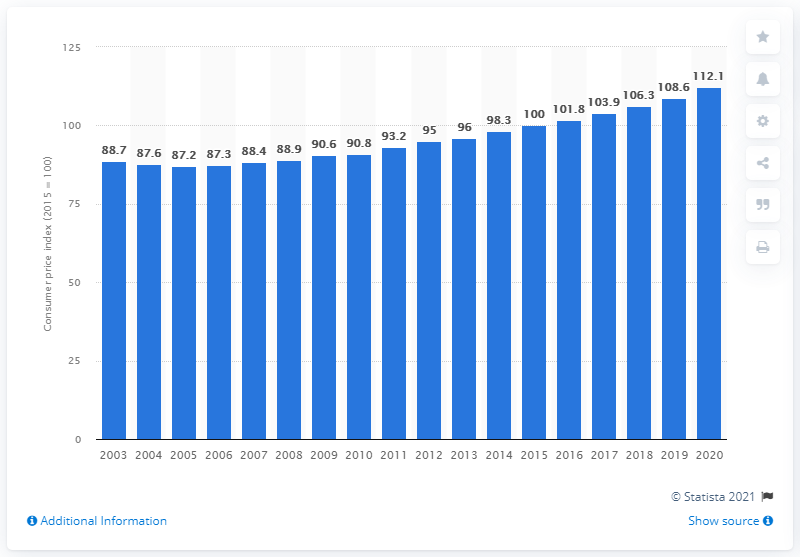Give some essential details in this illustration. In 2020, the cost index for pharmaceutical products in the United Kingdom was 112.1, indicating an increase in the prices of these products compared to the previous year. 